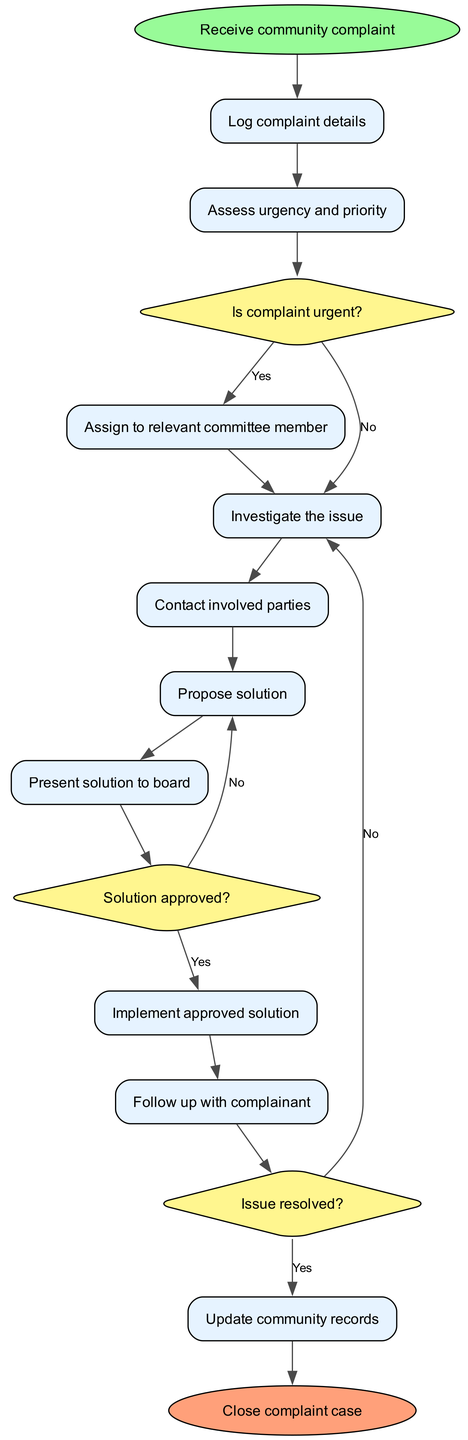What is the first action taken after receiving a community complaint? The diagram indicates that the first action taken after receiving a community complaint is to 'Log complaint details.' This can be seen directly as the first node following the start point.
Answer: Log complaint details How many decision points are there in this flowchart? The diagram shows a total of three decision points. Each decision is labelled as a diamond shape, and they can be counted directly in the decision section of the flowchart.
Answer: 3 What do you do if the complaint is not urgent? If the complaint is not urgent, the diagram indicates you move to the next step, which is 'Investigate the issue,' taking the 'No' path from the first decision point.
Answer: Investigate the issue What is the last step before closing the complaint case? The last step before closing the complaint case, according to the flowchart, is 'Update community records,' which comes just before the final 'Close complaint case' node.
Answer: Update community records If a solution is proposed but not approved, what is the next step? If the proposed solution is not approved, the next step per the diagram is to go back and revisit the 'Propose solution' node, as indicated by the 'No' path taken from the second decision point.
Answer: Propose solution What happens after contacting the involved parties? After contacting the involved parties, the next action is 'Propose solution,' which is the subsequent node in the flow after that step, as depicted in the flowchart.
Answer: Propose solution What node follows the decision on whether the solution is approved? Following the decision on whether the solution is approved, if the answer is 'Yes,' the following node is 'Implement approved solution.' This indicates the flow of actions post-decision.
Answer: Implement approved solution What action is taken after the solution is implemented? After the solution is implemented, the next step is to 'Follow up with complainant,' which is indicated directly after the 'Implement approved solution' node in the flowchart.
Answer: Follow up with complainant 